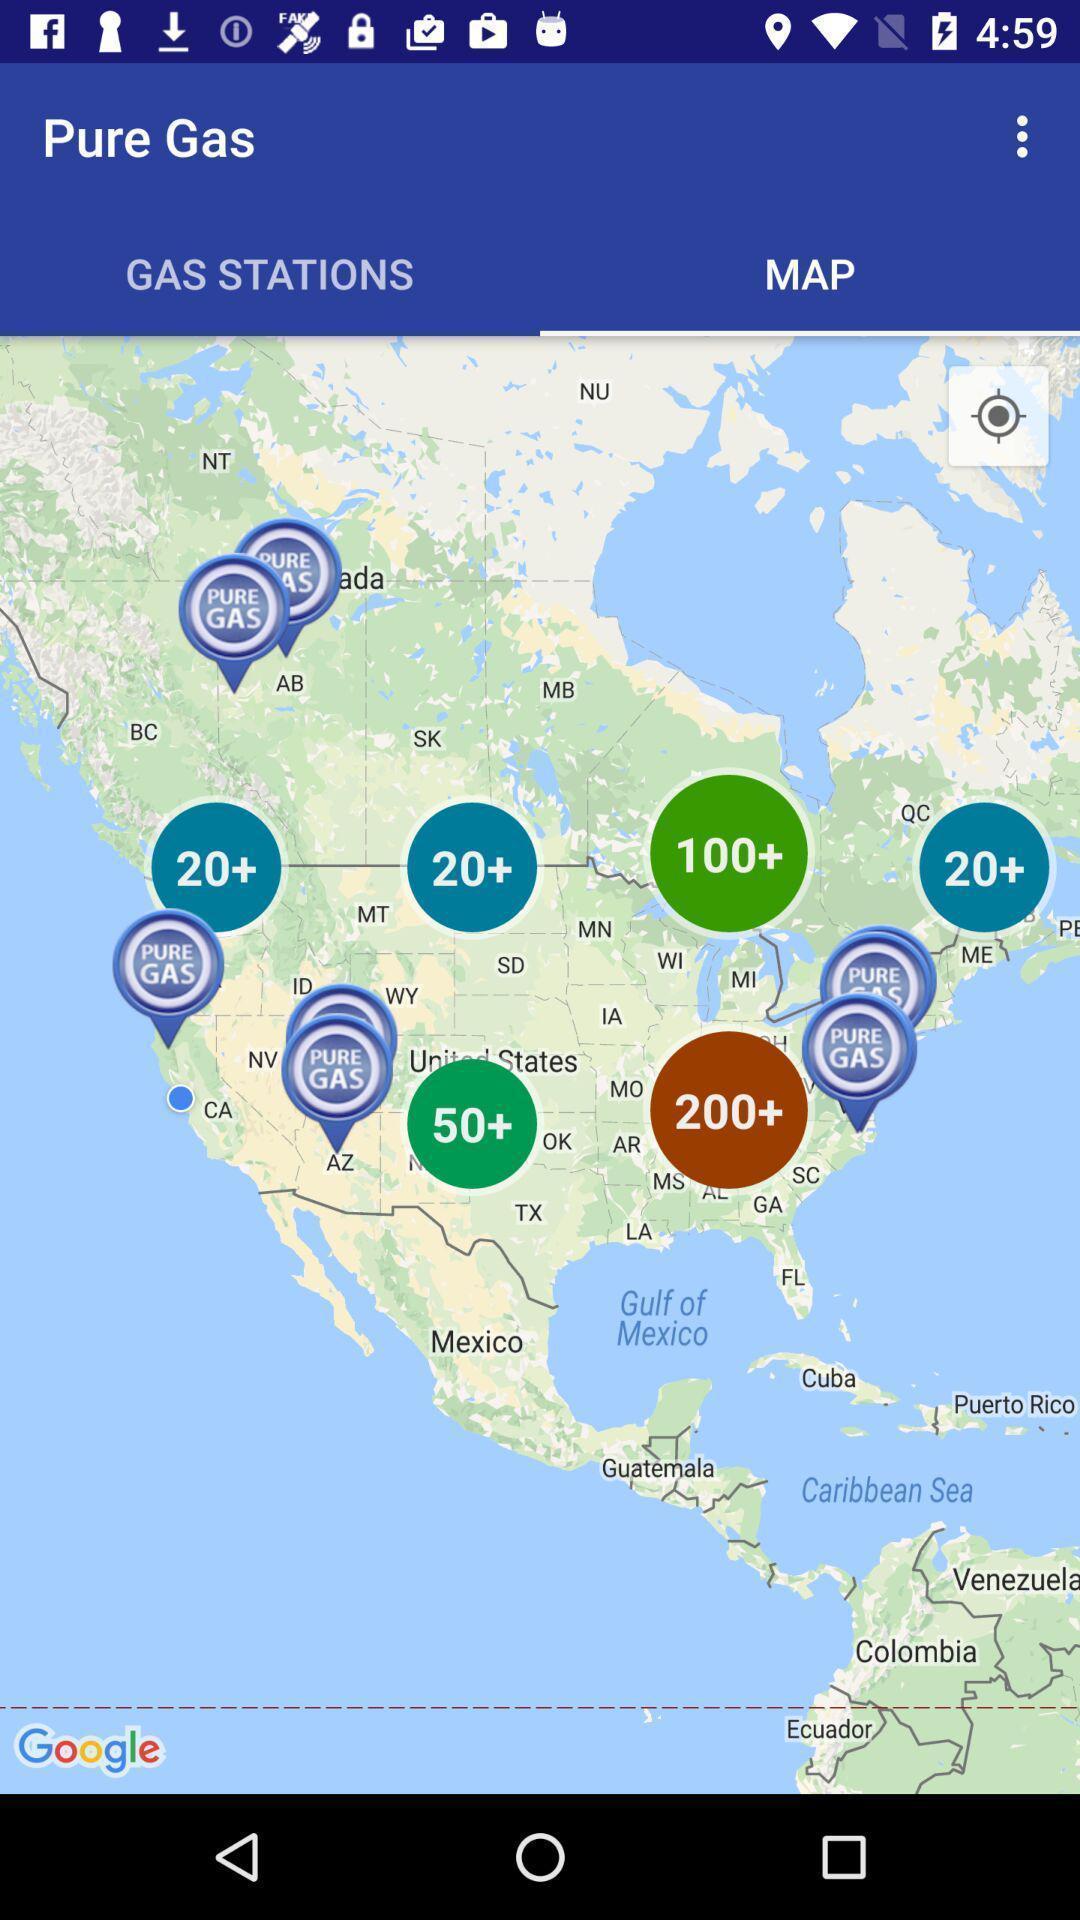Summarize the main components in this picture. Page displaying the locations of gas availability. 